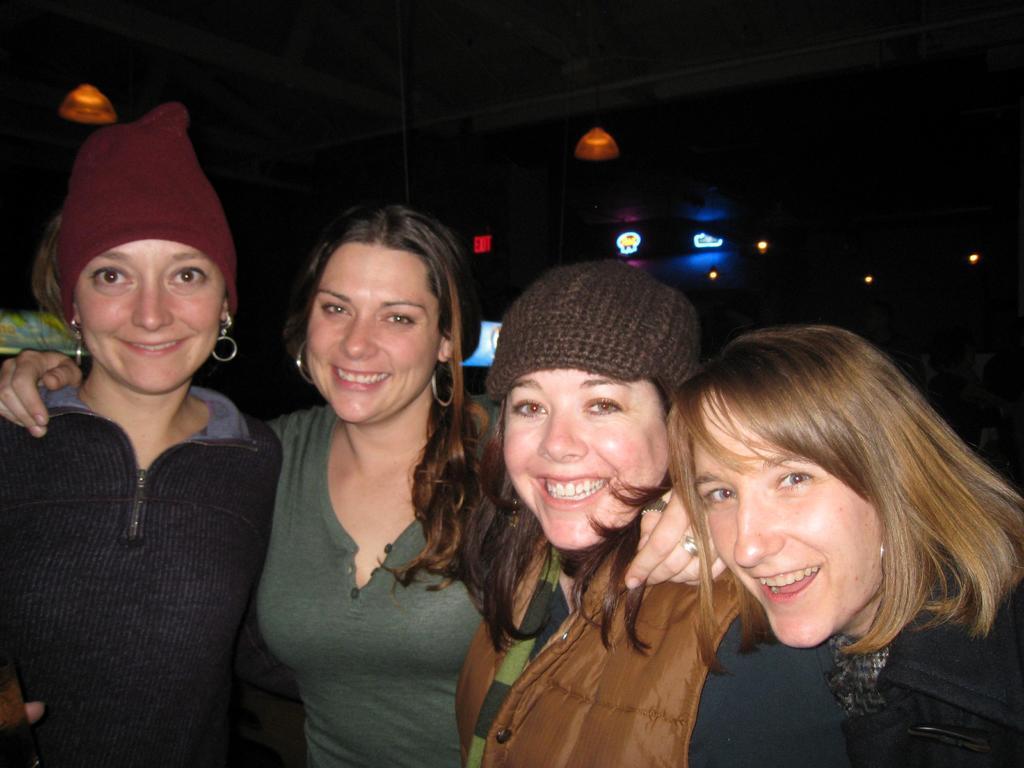Could you give a brief overview of what you see in this image? In this image in front there are four people wearing a smile on their faces. In the background of the image there are lights. 